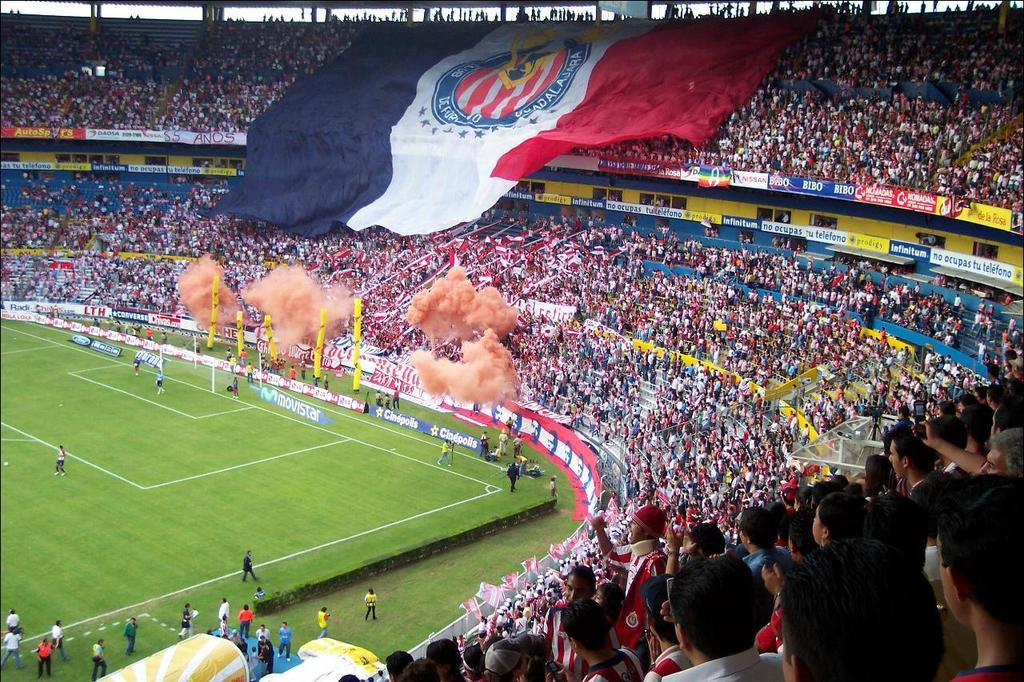What is the surface that the people are standing on in the image? The ground is covered with grass in the image. What are the spectators sitting on in the image? The spectators are sitting on chairs in the image. What can be seen on top of a pole or structure in the image? There is a flag on the top of something in the image. What type of wing can be seen on the people in the image? There are no wings visible on the people in the image. What does the aftermath of the event in the image look like? The provided facts do not mention any event or its aftermath, so it cannot be described. 